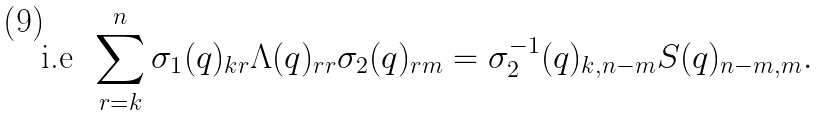<formula> <loc_0><loc_0><loc_500><loc_500>\text {i.e\, } \sum _ { r = k } ^ { n } \sigma _ { 1 } ( q ) _ { k r } \Lambda ( q ) _ { r r } \sigma _ { 2 } ( q ) _ { r m } = \sigma _ { 2 } ^ { - 1 } ( q ) _ { k , n - m } S ( q ) _ { n - m , m } .</formula> 